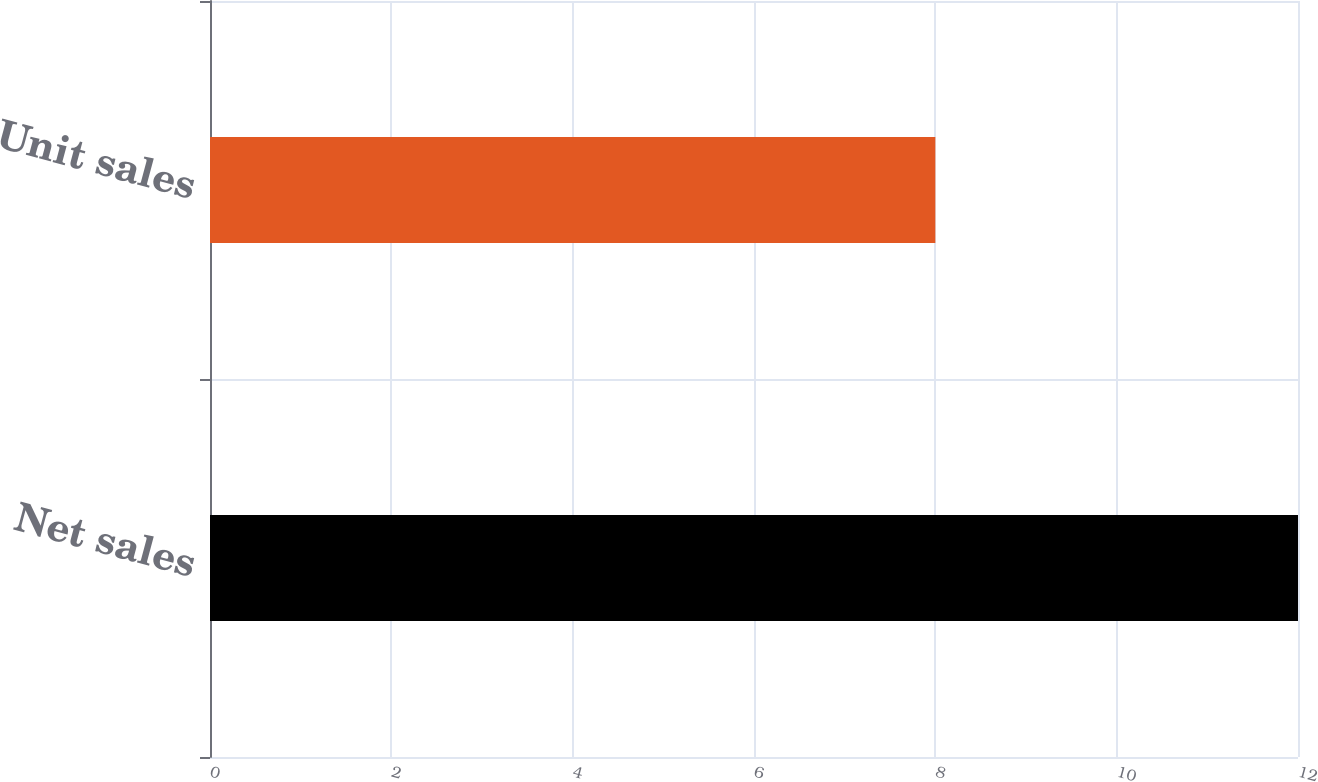Convert chart to OTSL. <chart><loc_0><loc_0><loc_500><loc_500><bar_chart><fcel>Net sales<fcel>Unit sales<nl><fcel>12<fcel>8<nl></chart> 